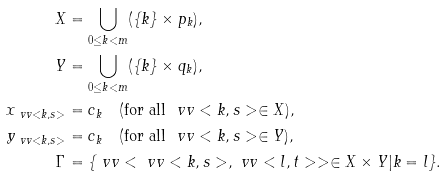Convert formula to latex. <formula><loc_0><loc_0><loc_500><loc_500>X & = \bigcup _ { 0 \leq k < m } ( \{ k \} \times p _ { k } ) , \\ Y & = \bigcup _ { 0 \leq k < m } ( \{ k \} \times q _ { k } ) , \\ x _ { \ v v < k , s > } & = c _ { k } \quad ( \text {for all} \ \ v v < k , s > \in X ) , \\ y _ { \ v v < k , s > } & = c _ { k } \quad ( \text {for all} \ \ v v < k , s > \in Y ) , \\ \Gamma & = \{ \ v v < \ v v < k , s > , \ v v < l , t > > \in X \times Y | k = l \} .</formula> 